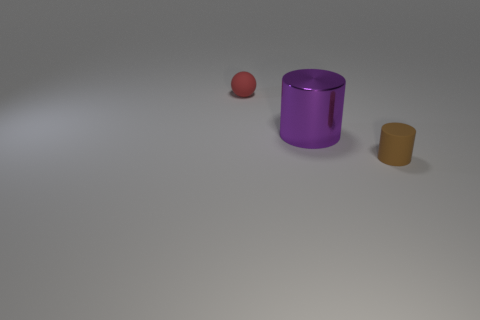Subtract all purple cylinders. How many cylinders are left? 1 Add 1 red cylinders. How many objects exist? 4 Subtract 1 spheres. How many spheres are left? 0 Subtract all balls. How many objects are left? 2 Subtract all purple cubes. How many blue spheres are left? 0 Subtract all cyan shiny cylinders. Subtract all cylinders. How many objects are left? 1 Add 2 purple metallic cylinders. How many purple metallic cylinders are left? 3 Add 1 purple rubber blocks. How many purple rubber blocks exist? 1 Subtract 0 gray cylinders. How many objects are left? 3 Subtract all gray cylinders. Subtract all yellow cubes. How many cylinders are left? 2 